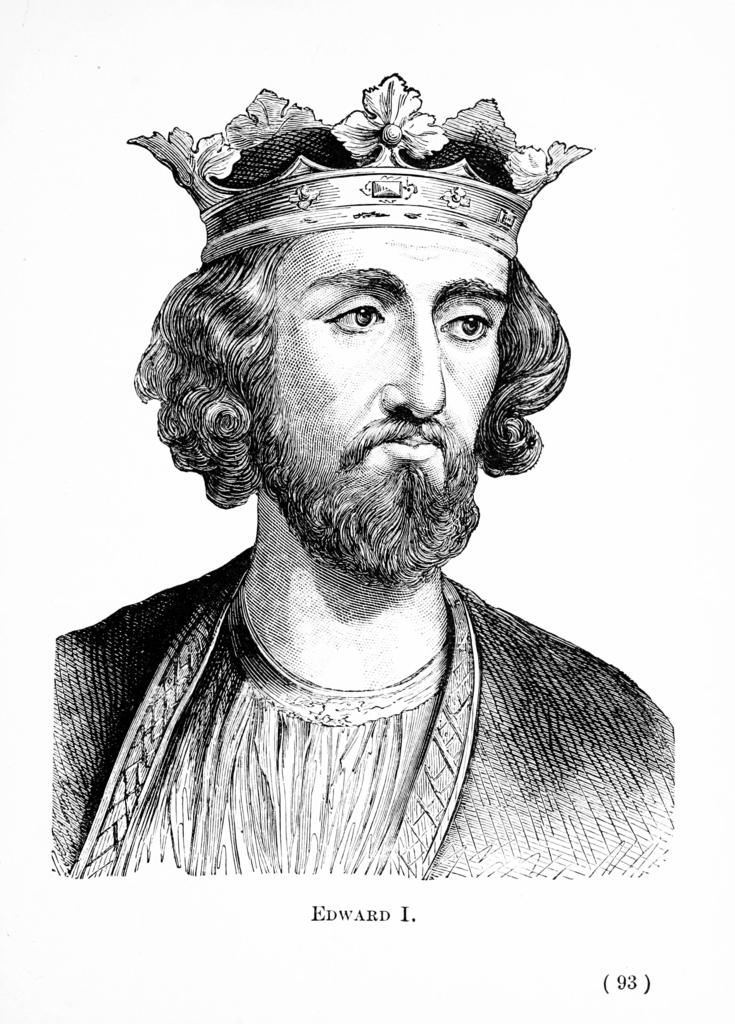What is depicted in the image? There is a sketch of a person in the image. What else can be seen in the image besides the sketch? There is text and a number in the image. How many birds are perched on the person's elbow in the image? There are no birds present in the image, and therefore no birds can be seen on the person's elbow. 